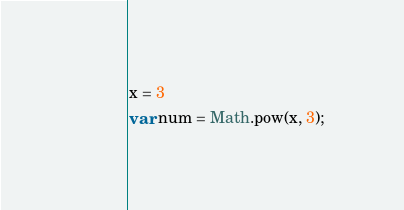Convert code to text. <code><loc_0><loc_0><loc_500><loc_500><_JavaScript_>x = 3
var num = Math.pow(x, 3);</code> 